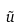Convert formula to latex. <formula><loc_0><loc_0><loc_500><loc_500>\tilde { u }</formula> 